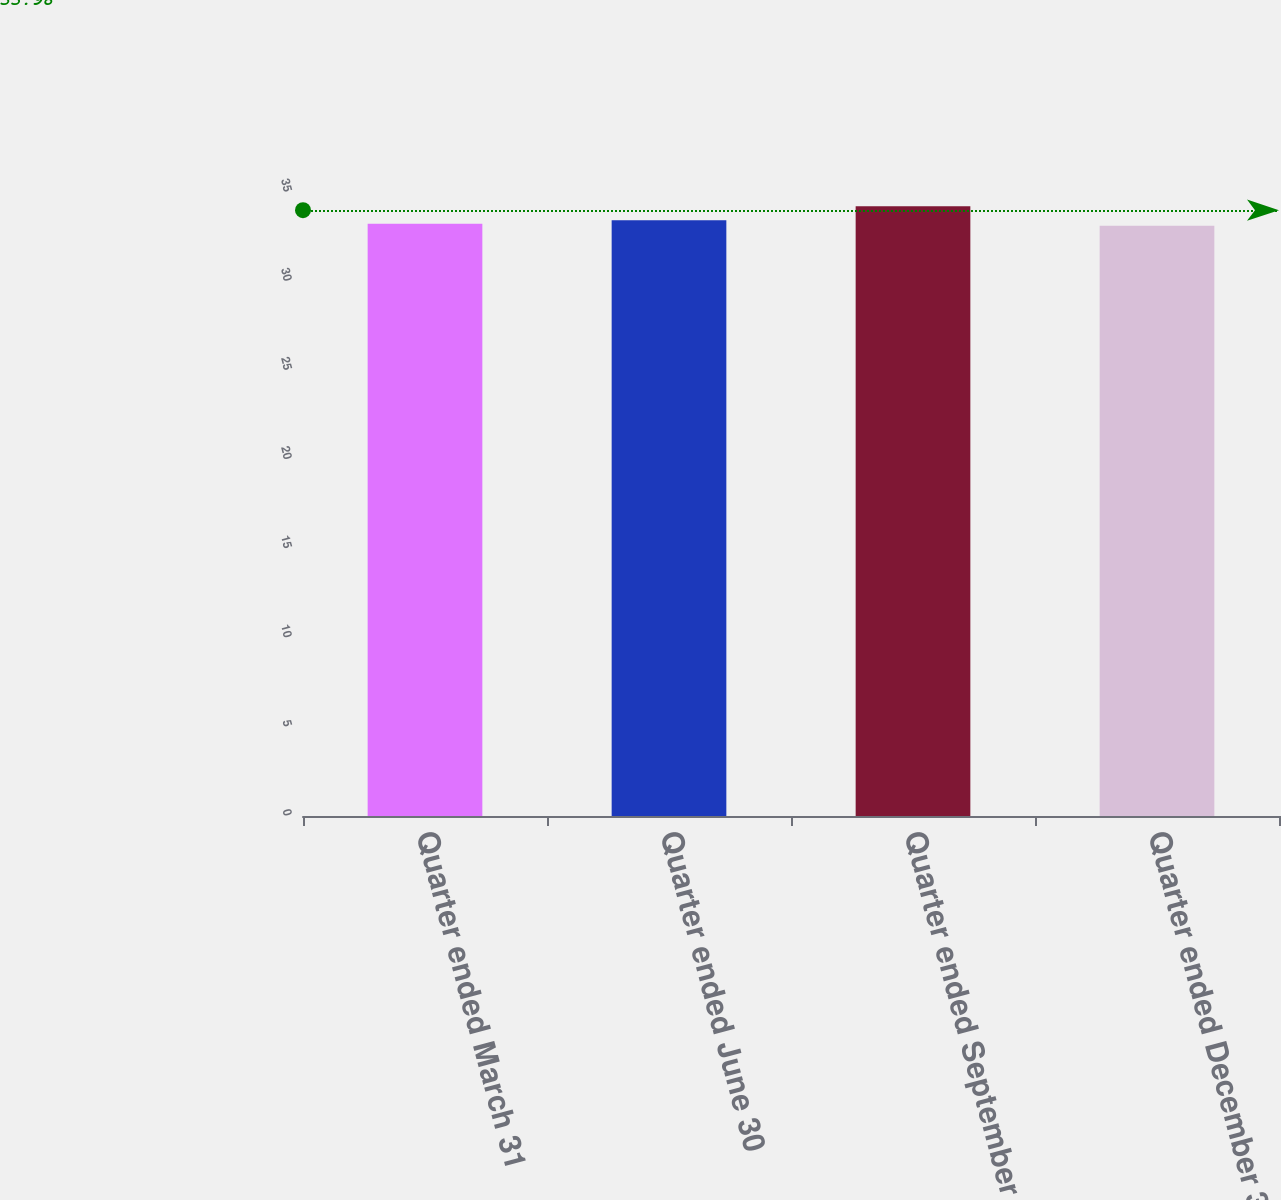<chart> <loc_0><loc_0><loc_500><loc_500><bar_chart><fcel>Quarter ended March 31<fcel>Quarter ended June 30<fcel>Quarter ended September 30<fcel>Quarter ended December 31<nl><fcel>33.22<fcel>33.42<fcel>34.2<fcel>33.11<nl></chart> 